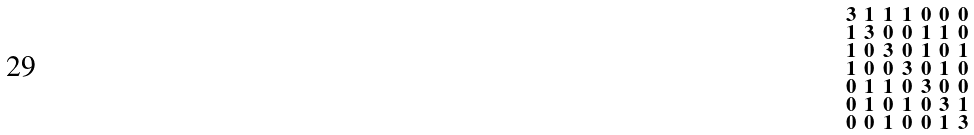Convert formula to latex. <formula><loc_0><loc_0><loc_500><loc_500>\begin{smallmatrix} 3 & 1 & 1 & 1 & 0 & 0 & 0 \\ 1 & 3 & 0 & 0 & 1 & 1 & 0 \\ 1 & 0 & 3 & 0 & 1 & 0 & 1 \\ 1 & 0 & 0 & 3 & 0 & 1 & 0 \\ 0 & 1 & 1 & 0 & 3 & 0 & 0 \\ 0 & 1 & 0 & 1 & 0 & 3 & 1 \\ 0 & 0 & 1 & 0 & 0 & 1 & 3 \end{smallmatrix}</formula> 